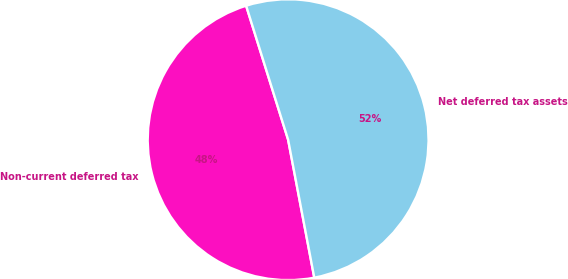Convert chart to OTSL. <chart><loc_0><loc_0><loc_500><loc_500><pie_chart><fcel>Non-current deferred tax<fcel>Net deferred tax assets<nl><fcel>48.15%<fcel>51.85%<nl></chart> 